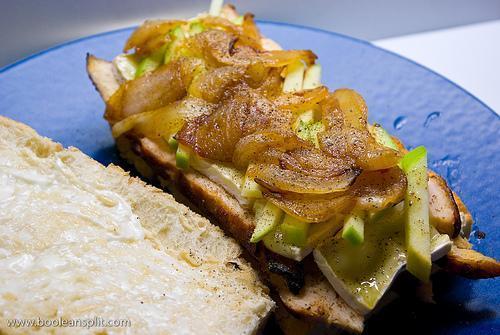How many dining tables are there?
Give a very brief answer. 2. 